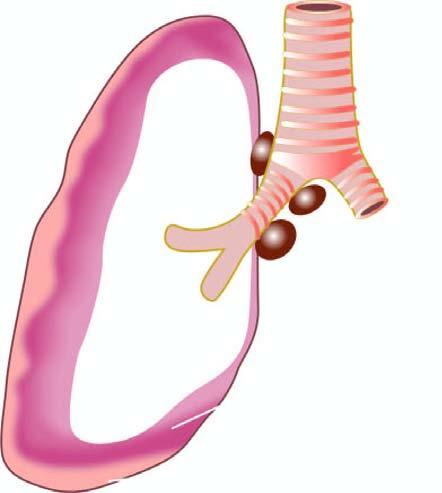what is the tumour seen to form?
Answer the question using a single word or phrase. Thick 